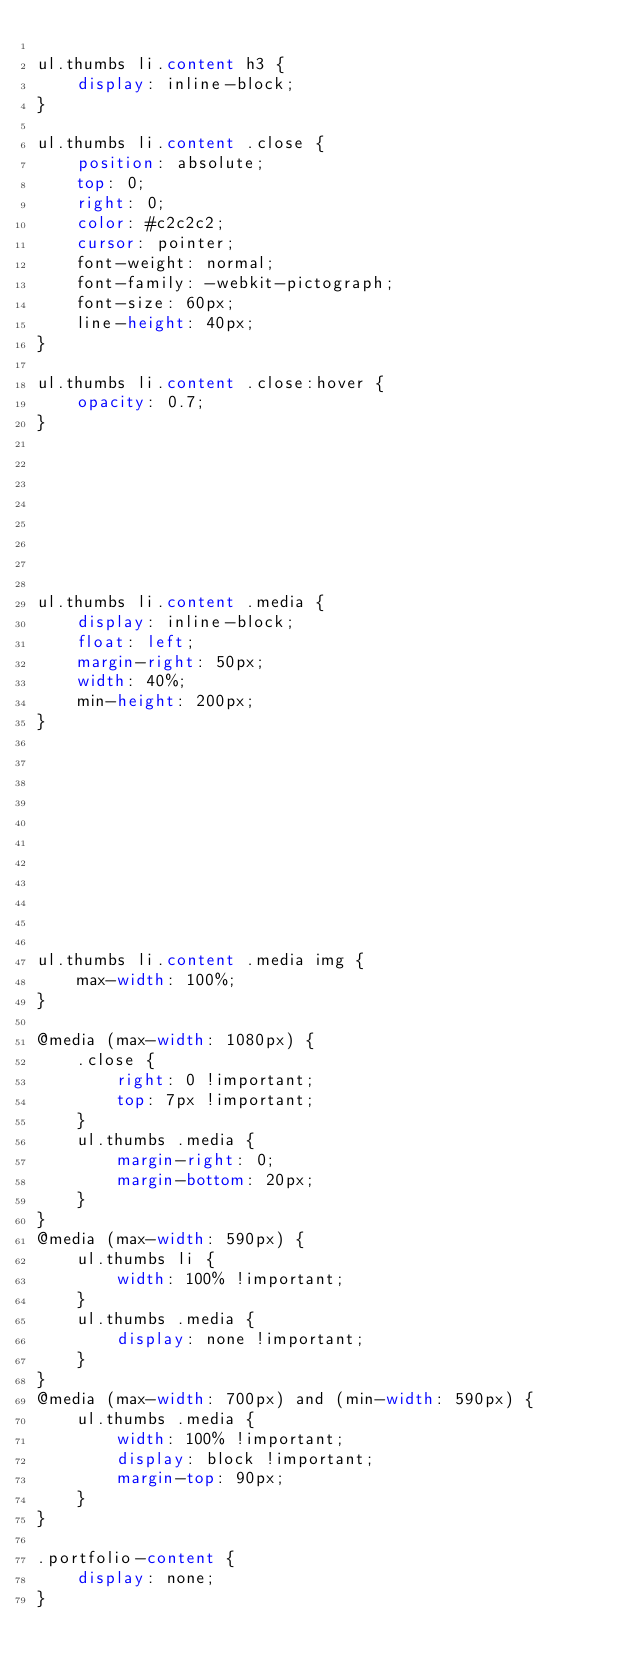Convert code to text. <code><loc_0><loc_0><loc_500><loc_500><_CSS_>
ul.thumbs li.content h3 {
    display: inline-block;
}

ul.thumbs li.content .close {
    position: absolute;
    top: 0;
    right: 0;
    color: #c2c2c2;
    cursor: pointer;
    font-weight: normal;
    font-family: -webkit-pictograph;
    font-size: 60px;
    line-height: 40px;
}

ul.thumbs li.content .close:hover {
    opacity: 0.7;
}








ul.thumbs li.content .media {
    display: inline-block;
    float: left;
    margin-right: 50px;
    width: 40%;
    min-height: 200px;
}











ul.thumbs li.content .media img {
    max-width: 100%;
}

@media (max-width: 1080px) {
	.close {
		right: 0 !important;
		top: 7px !important;
	}
	ul.thumbs .media {
		margin-right: 0;
		margin-bottom: 20px;
	}
}
@media (max-width: 590px) {
	ul.thumbs li {
		width: 100% !important;
	}
	ul.thumbs .media {
		display: none !important;
	}
}
@media (max-width: 700px) and (min-width: 590px) {
	ul.thumbs .media {
		width: 100% !important;
		display: block !important;
		margin-top: 90px;
	}
}

.portfolio-content {
    display: none;
}
</code> 